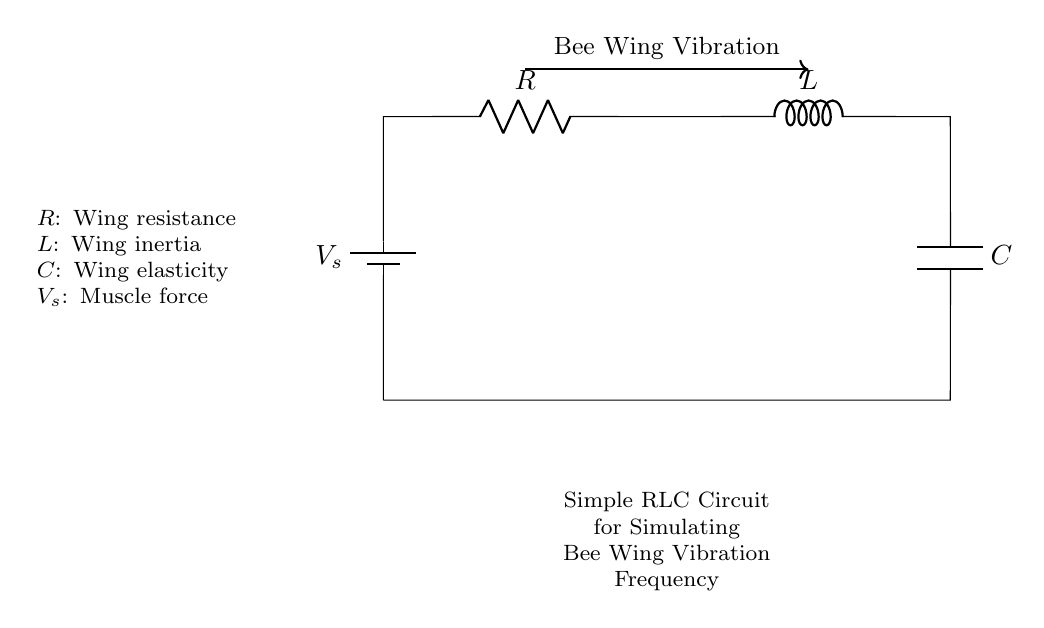What is the resistance represented in the circuit? The resistance is labeled as R in the circuit diagram. It represents wing resistance in the context of simulating bee wing vibration.
Answer: R What component represents wing inertia? The component representing wing inertia is labeled as L. It is an inductor in this circuit, reflecting the mass of the bee's wings.
Answer: L Which component simulates wing elasticity? The component that simulates wing elasticity is labeled as C. It acts as a capacitor in the circuit, representing the flexibility of the wings.
Answer: C How does the bee wing vibration relate to the circuit? The arrow indicating "Bee Wing Vibration" connects the RLC components, showing that this circuit simulates the vibration frequency of bee wings by using the resistance, inductance, and capacitance.
Answer: Vibration connection If the circuit is powered by a muscle force of 5 volts, what type of voltage source is shown? The voltage source in the circuit is labeled as V_s, indicating that it is a battery supplying voltage to drive the current through the RLC components representing the bee wing system.
Answer: Battery Explain the function of the inductor in this circuit. The inductor (L) in this RLC circuit stores energy in a magnetic field when current flows through it. It affects the frequency of the oscillation in the circuit, similar to how the inertia of bee wings affects their vibration frequency during flight.
Answer: Energy storing What is the role of the resistor in simulating bee wings? The resistor (R) represents the damping effect of the wing resistance in the circuit, modeling energy loss due to drag and inefficiency in wing movement during vibrations.
Answer: Damping effect 